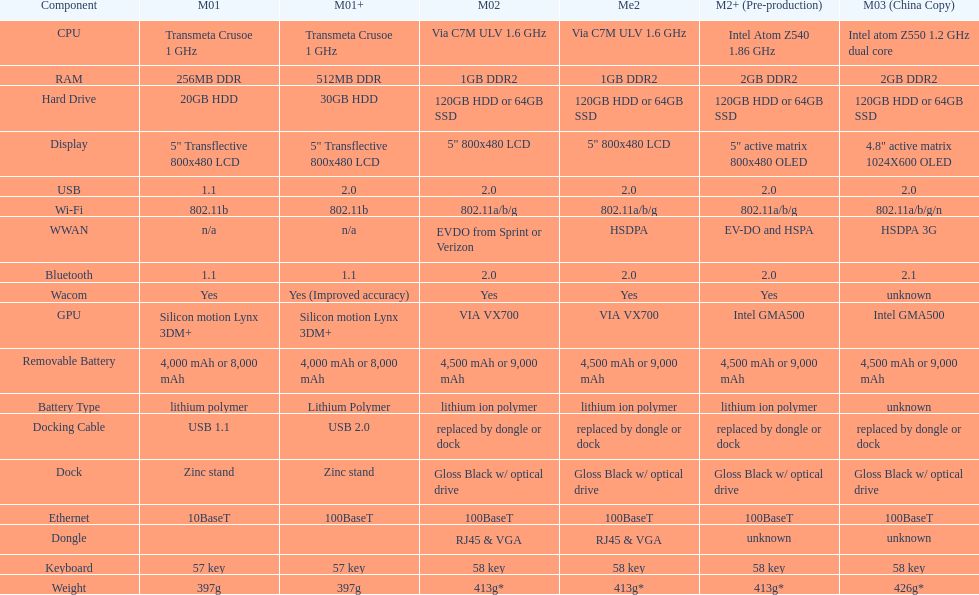Can you give me this table as a dict? {'header': ['Component', 'M01', 'M01+', 'M02', 'Me2', 'M2+ (Pre-production)', 'M03 (China Copy)'], 'rows': [['CPU', 'Transmeta Crusoe 1\xa0GHz', 'Transmeta Crusoe 1\xa0GHz', 'Via C7M ULV 1.6\xa0GHz', 'Via C7M ULV 1.6\xa0GHz', 'Intel Atom Z540 1.86\xa0GHz', 'Intel atom Z550 1.2\xa0GHz dual core'], ['RAM', '256MB DDR', '512MB DDR', '1GB DDR2', '1GB DDR2', '2GB DDR2', '2GB DDR2'], ['Hard Drive', '20GB HDD', '30GB HDD', '120GB HDD or 64GB SSD', '120GB HDD or 64GB SSD', '120GB HDD or 64GB SSD', '120GB HDD or 64GB SSD'], ['Display', '5" Transflective 800x480 LCD', '5" Transflective 800x480 LCD', '5" 800x480 LCD', '5" 800x480 LCD', '5" active matrix 800x480 OLED', '4.8" active matrix 1024X600 OLED'], ['USB', '1.1', '2.0', '2.0', '2.0', '2.0', '2.0'], ['Wi-Fi', '802.11b', '802.11b', '802.11a/b/g', '802.11a/b/g', '802.11a/b/g', '802.11a/b/g/n'], ['WWAN', 'n/a', 'n/a', 'EVDO from Sprint or Verizon', 'HSDPA', 'EV-DO and HSPA', 'HSDPA 3G'], ['Bluetooth', '1.1', '1.1', '2.0', '2.0', '2.0', '2.1'], ['Wacom', 'Yes', 'Yes (Improved accuracy)', 'Yes', 'Yes', 'Yes', 'unknown'], ['GPU', 'Silicon motion Lynx 3DM+', 'Silicon motion Lynx 3DM+', 'VIA VX700', 'VIA VX700', 'Intel GMA500', 'Intel GMA500'], ['Removable Battery', '4,000 mAh or 8,000 mAh', '4,000 mAh or 8,000 mAh', '4,500 mAh or 9,000 mAh', '4,500 mAh or 9,000 mAh', '4,500 mAh or 9,000 mAh', '4,500 mAh or 9,000 mAh'], ['Battery Type', 'lithium polymer', 'Lithium Polymer', 'lithium ion polymer', 'lithium ion polymer', 'lithium ion polymer', 'unknown'], ['Docking Cable', 'USB 1.1', 'USB 2.0', 'replaced by dongle or dock', 'replaced by dongle or dock', 'replaced by dongle or dock', 'replaced by dongle or dock'], ['Dock', 'Zinc stand', 'Zinc stand', 'Gloss Black w/ optical drive', 'Gloss Black w/ optical drive', 'Gloss Black w/ optical drive', 'Gloss Black w/ optical drive'], ['Ethernet', '10BaseT', '100BaseT', '100BaseT', '100BaseT', '100BaseT', '100BaseT'], ['Dongle', '', '', 'RJ45 & VGA', 'RJ45 & VGA', 'unknown', 'unknown'], ['Keyboard', '57 key', '57 key', '58 key', '58 key', '58 key', '58 key'], ['Weight', '397g', '397g', '413g*', '413g*', '413g*', '426g*']]} Which element came before the usb? Display. 